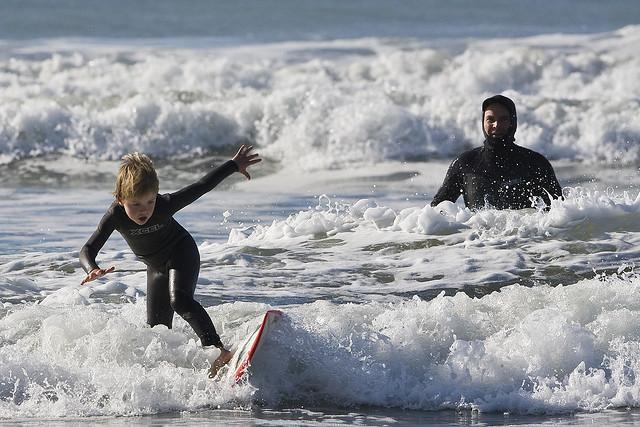Why are they wearing wetsuits? Please explain your reasoning. cold water. They want to be warm. 